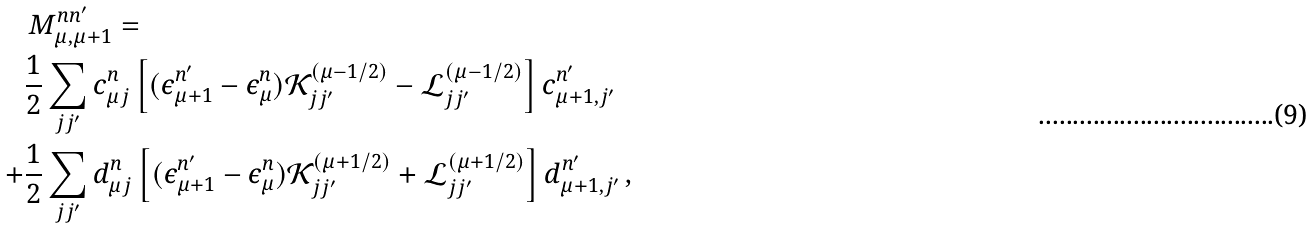<formula> <loc_0><loc_0><loc_500><loc_500>& \, M _ { \mu , \mu + 1 } ^ { n n ^ { \prime } } = \\ & \frac { 1 } { 2 } \sum _ { j j ^ { \prime } } c _ { \mu j } ^ { n } \left [ ( \epsilon _ { \mu + 1 } ^ { n ^ { \prime } } - \epsilon _ { \mu } ^ { n } ) \mathcal { K } _ { j j ^ { \prime } } ^ { ( \mu - 1 / 2 ) } - \mathcal { L } _ { j j ^ { \prime } } ^ { ( \mu - 1 / 2 ) } \right ] c _ { \mu + 1 , j ^ { \prime } } ^ { n ^ { \prime } } \\ + & \frac { 1 } { 2 } \sum _ { j j ^ { \prime } } d _ { \mu j } ^ { n } \left [ ( \epsilon _ { \mu + 1 } ^ { n ^ { \prime } } - \epsilon _ { \mu } ^ { n } ) \mathcal { K } _ { j j ^ { \prime } } ^ { ( \mu + 1 / 2 ) } + \mathcal { L } _ { j j ^ { \prime } } ^ { ( \mu + 1 / 2 ) } \right ] d _ { \mu + 1 , j ^ { \prime } } ^ { n ^ { \prime } } \, ,</formula> 